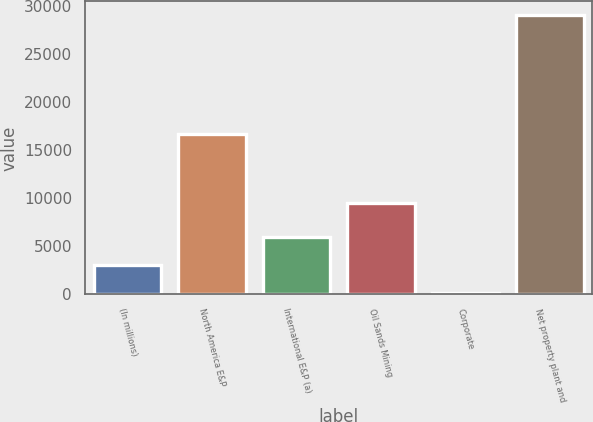<chart> <loc_0><loc_0><loc_500><loc_500><bar_chart><fcel>(In millions)<fcel>North America E&P<fcel>International E&P (a)<fcel>Oil Sands Mining<fcel>Corporate<fcel>Net property plant and<nl><fcel>3018.3<fcel>16717<fcel>5909.6<fcel>9455<fcel>127<fcel>29040<nl></chart> 